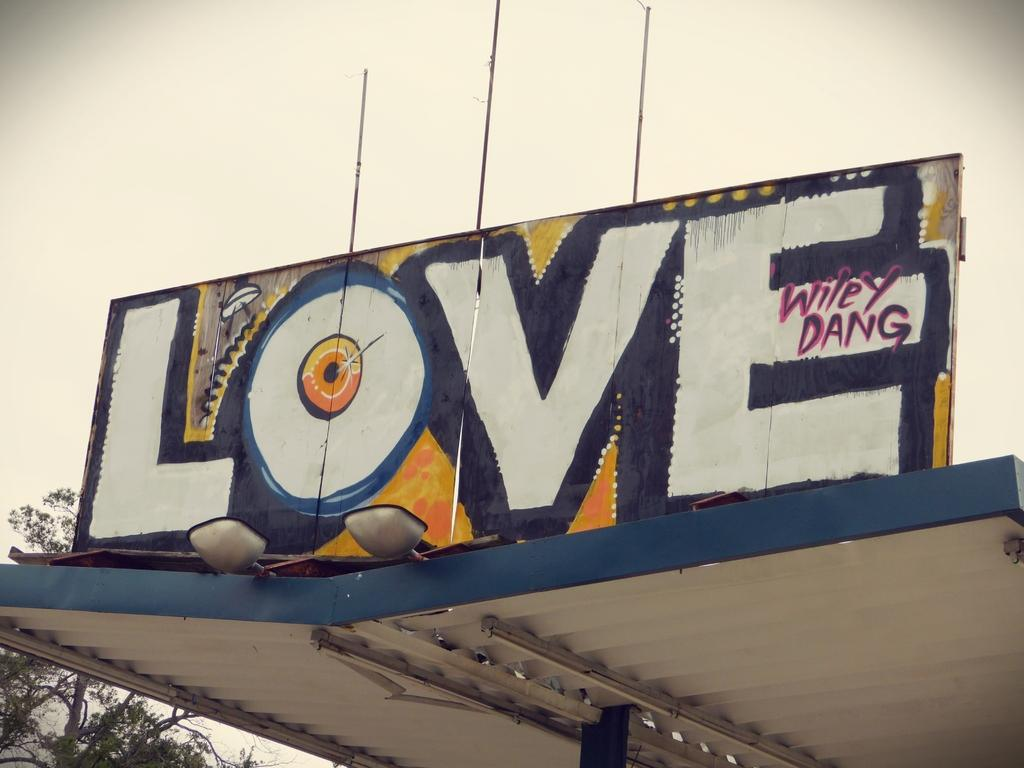<image>
Relay a brief, clear account of the picture shown. The word love is painted onto a sign sitting on an overhang. 